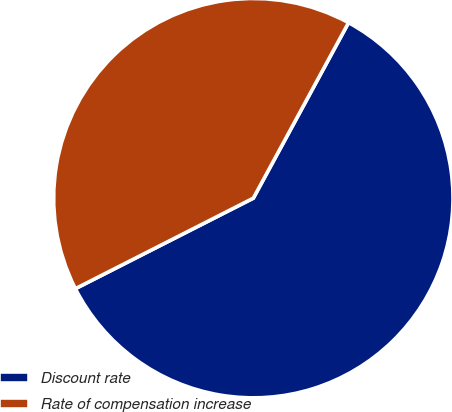Convert chart to OTSL. <chart><loc_0><loc_0><loc_500><loc_500><pie_chart><fcel>Discount rate<fcel>Rate of compensation increase<nl><fcel>59.6%<fcel>40.4%<nl></chart> 